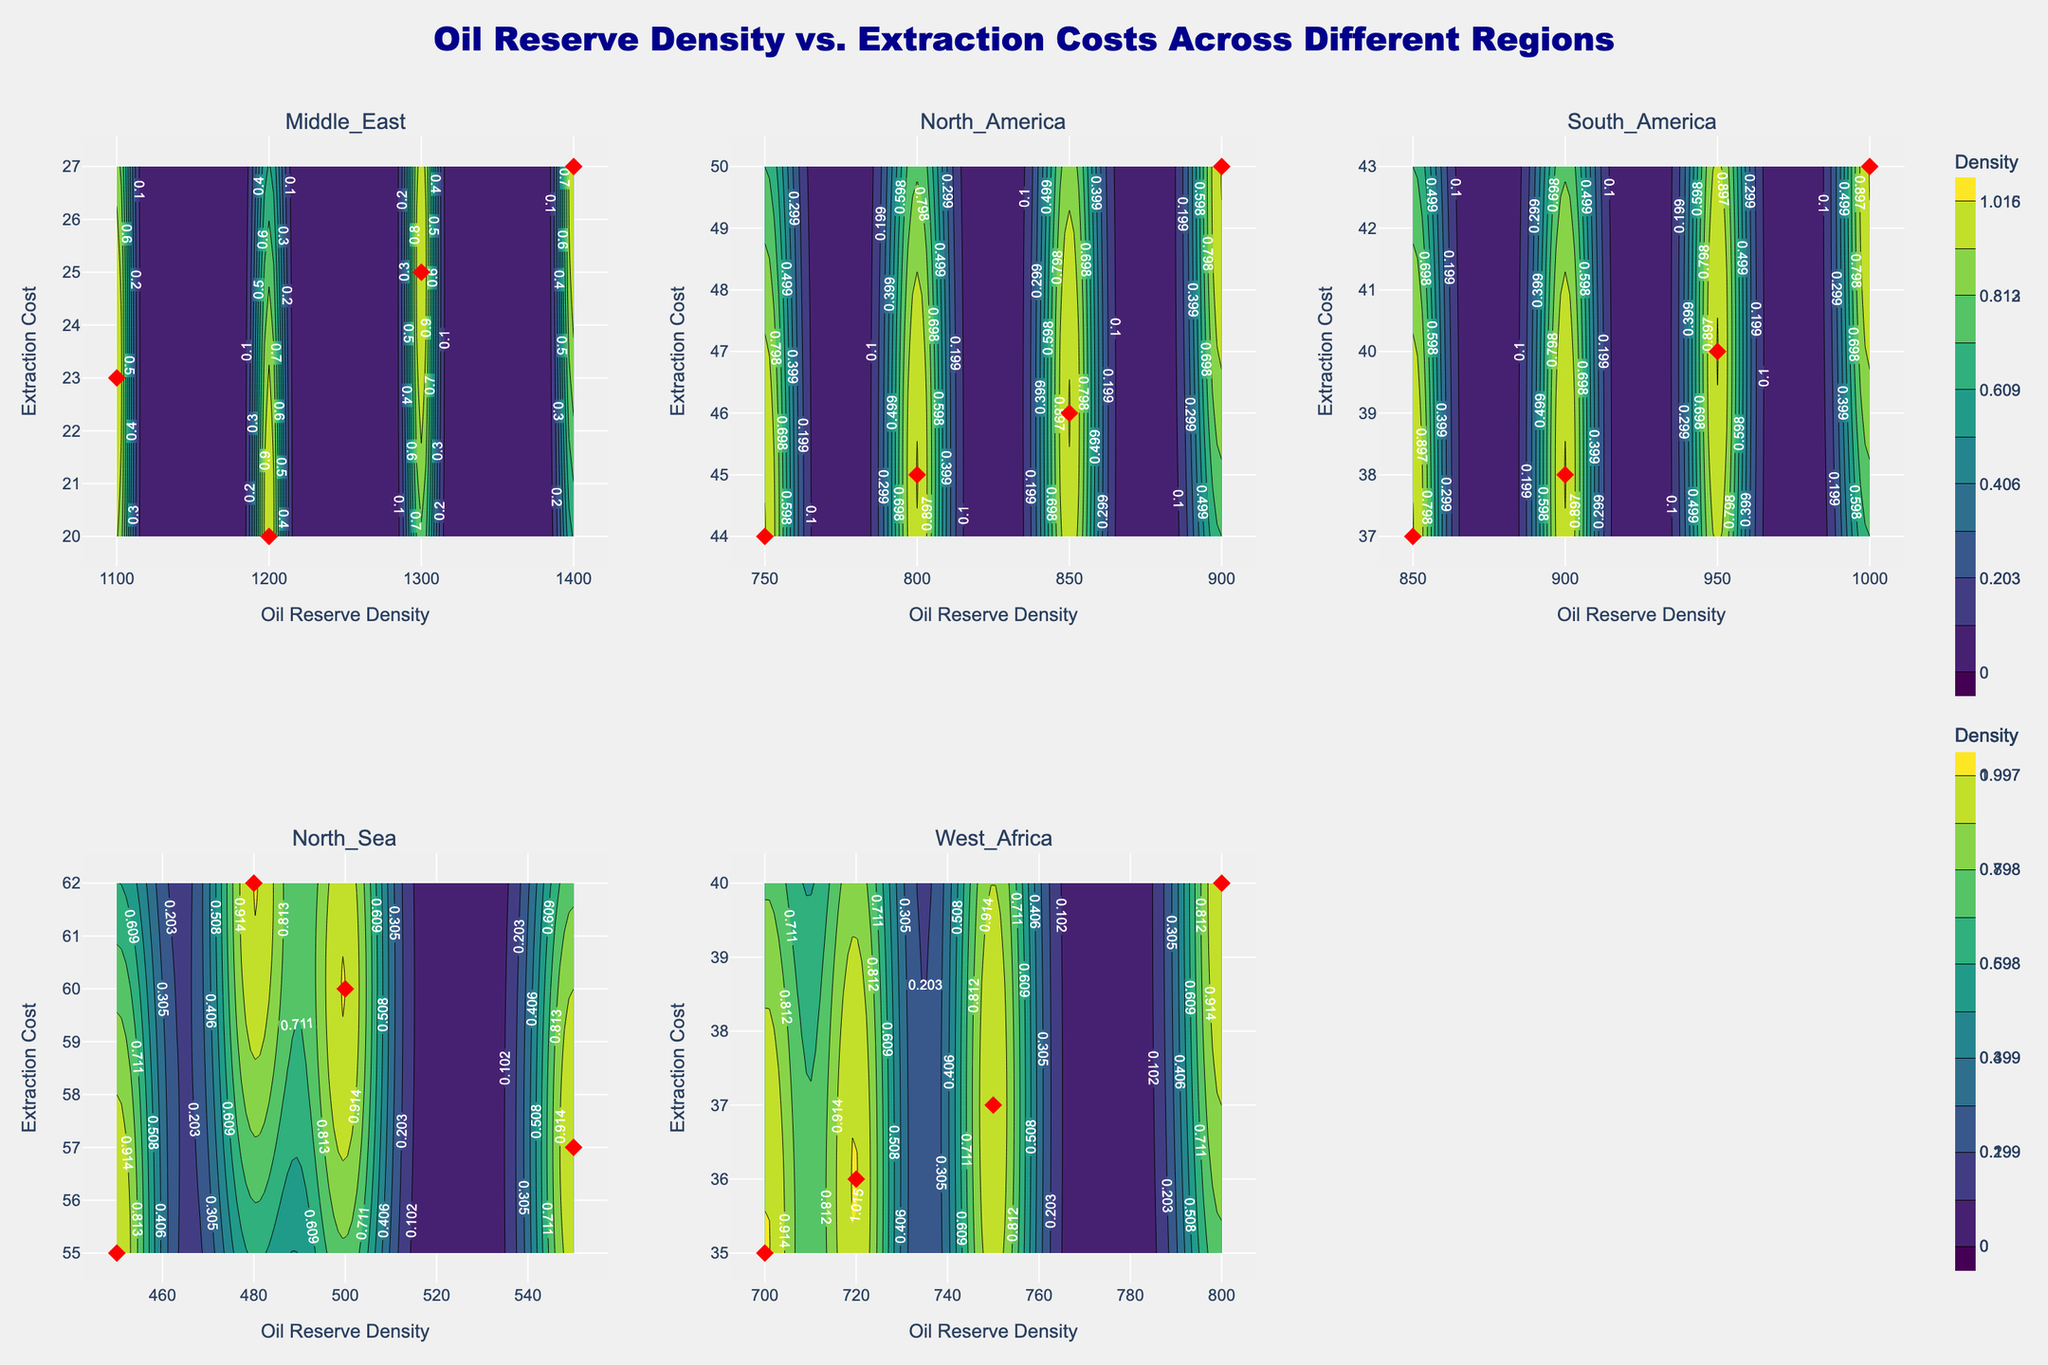What is the title of the figure? The title is displayed at the top center of the figure and reads: "Oil Reserve Density vs. Extraction Costs Across Different Regions."
Answer: Oil Reserve Density vs. Extraction Costs Across Different Regions How many regions are examined in this figure? The figure consists of six subplots, each representing a different region. The subplot titles indicate the regions examined.
Answer: Five Which region has the highest Extraction Costs on average? To determine the region with the highest extraction costs on average, observe the y-values (Extraction Cost) for each region and compare their general positions. The North Sea has the highest values on the y-axis.
Answer: North Sea What is the color scale used for the contour plots? Look at the color gradient in each subplot, which represents the density of oil reserves. It spans from lighter to darker shades and uses the 'Viridis' color scale.
Answer: Viridis In which region is the Oil Reserve Density most varied? Examine the x-axis range for each subplot (Oil Reserve Density). The Middle East shows the widest range of values, indicating the most variation.
Answer: Middle East What's the maximum Oil Reserve Density in South America? Refer to the x-axis in the South America subplot. Identify the highest x-value among the data points, which is 1000.
Answer: 1000 Which region has the lowest average Extraction Costs? Observe the general position of the y-values (Extraction Cost) for each region. West Africa has the lowest values on the y-axis.
Answer: West Africa Compare the Oil Reserve Density in Middle East and North Sea. Which is higher? Look at the x-axis range for both Middle East and North Sea subplots. The Middle East has significantly higher values.
Answer: Middle East Which region shows the highest density of Oil Reserve Density and Extraction Cost overlap? Look at the color intensity of the contour plots. The Middle East subplot exhibits the highest density, as indicated by the darkest contours.
Answer: Middle East Is there a region where the Oil Reserve Density and Extraction Costs are relatively evenly distributed? Evaluate the spread and uniformity of data points. South America shows a relatively even distribution across a mid-range for both variables.
Answer: South America 